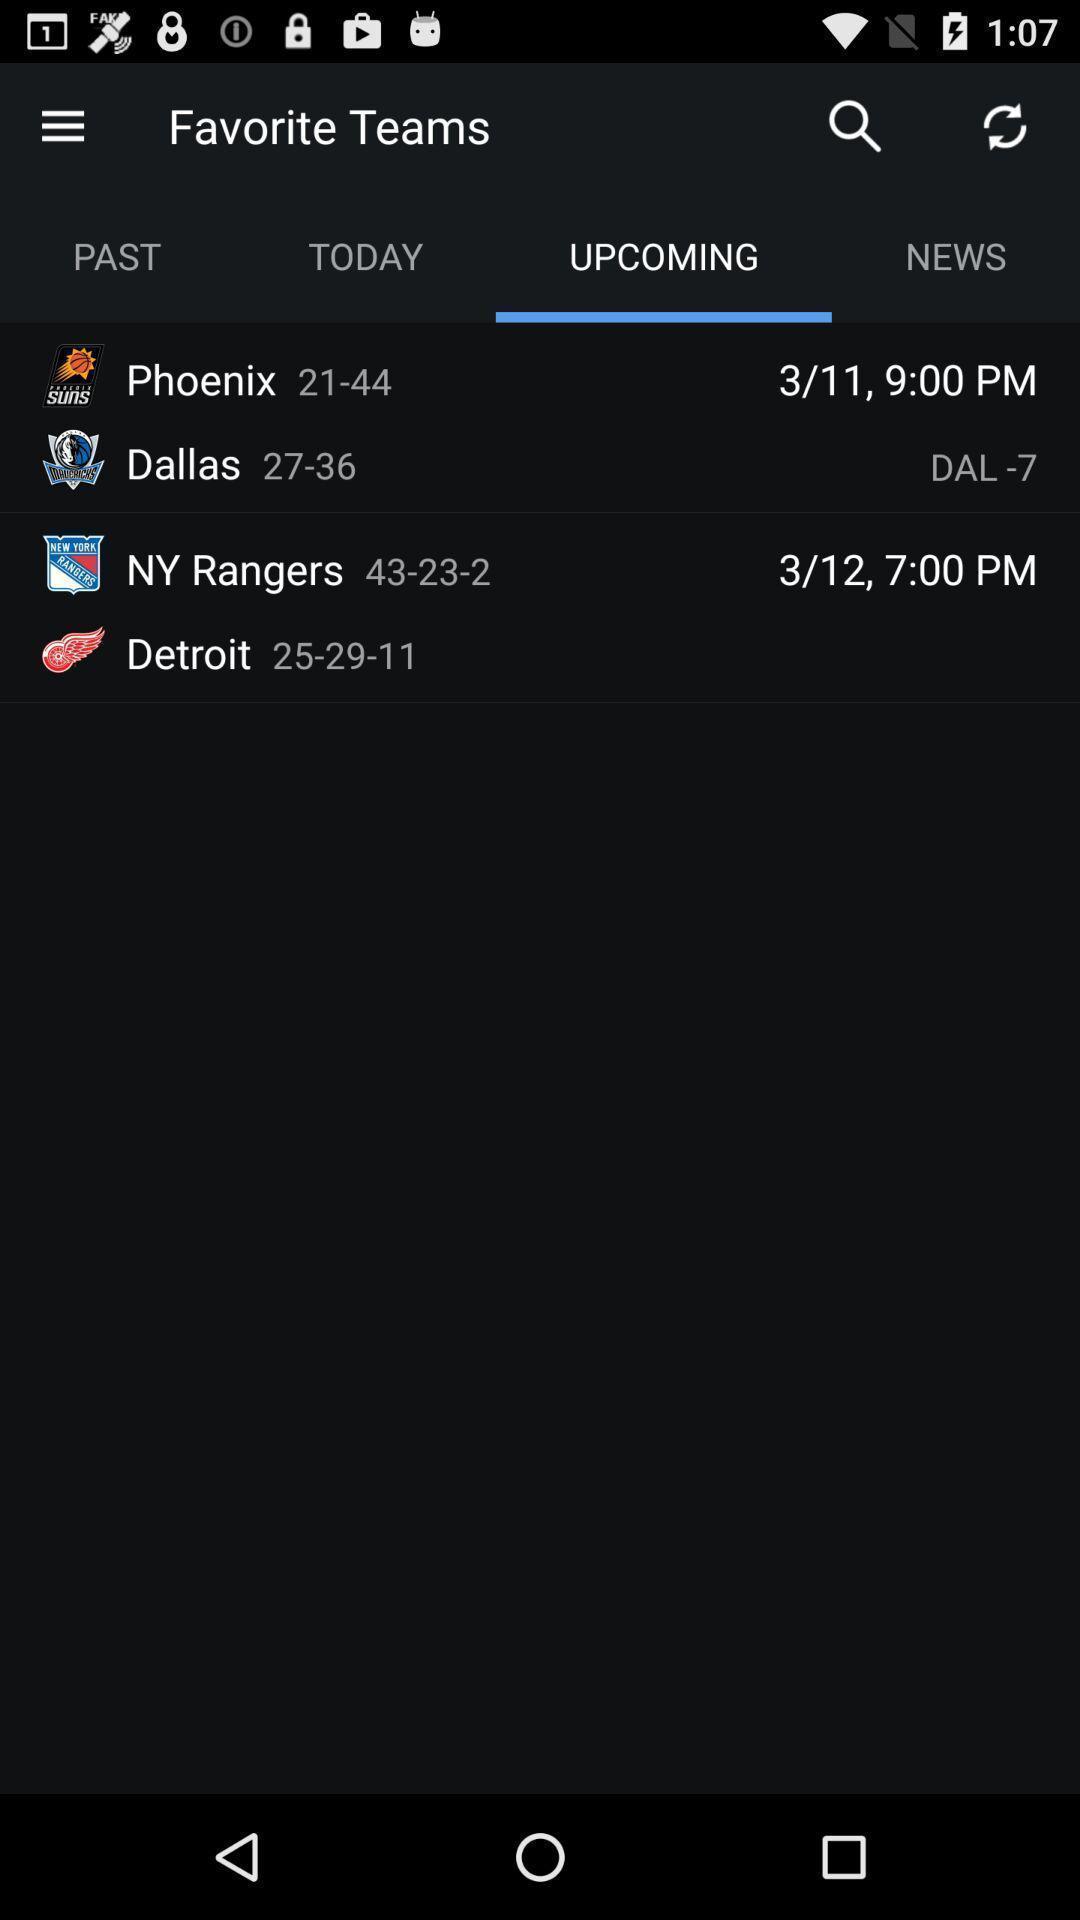Summarize the information in this screenshot. Page displaying upcoming favourite team list in a sports app. 